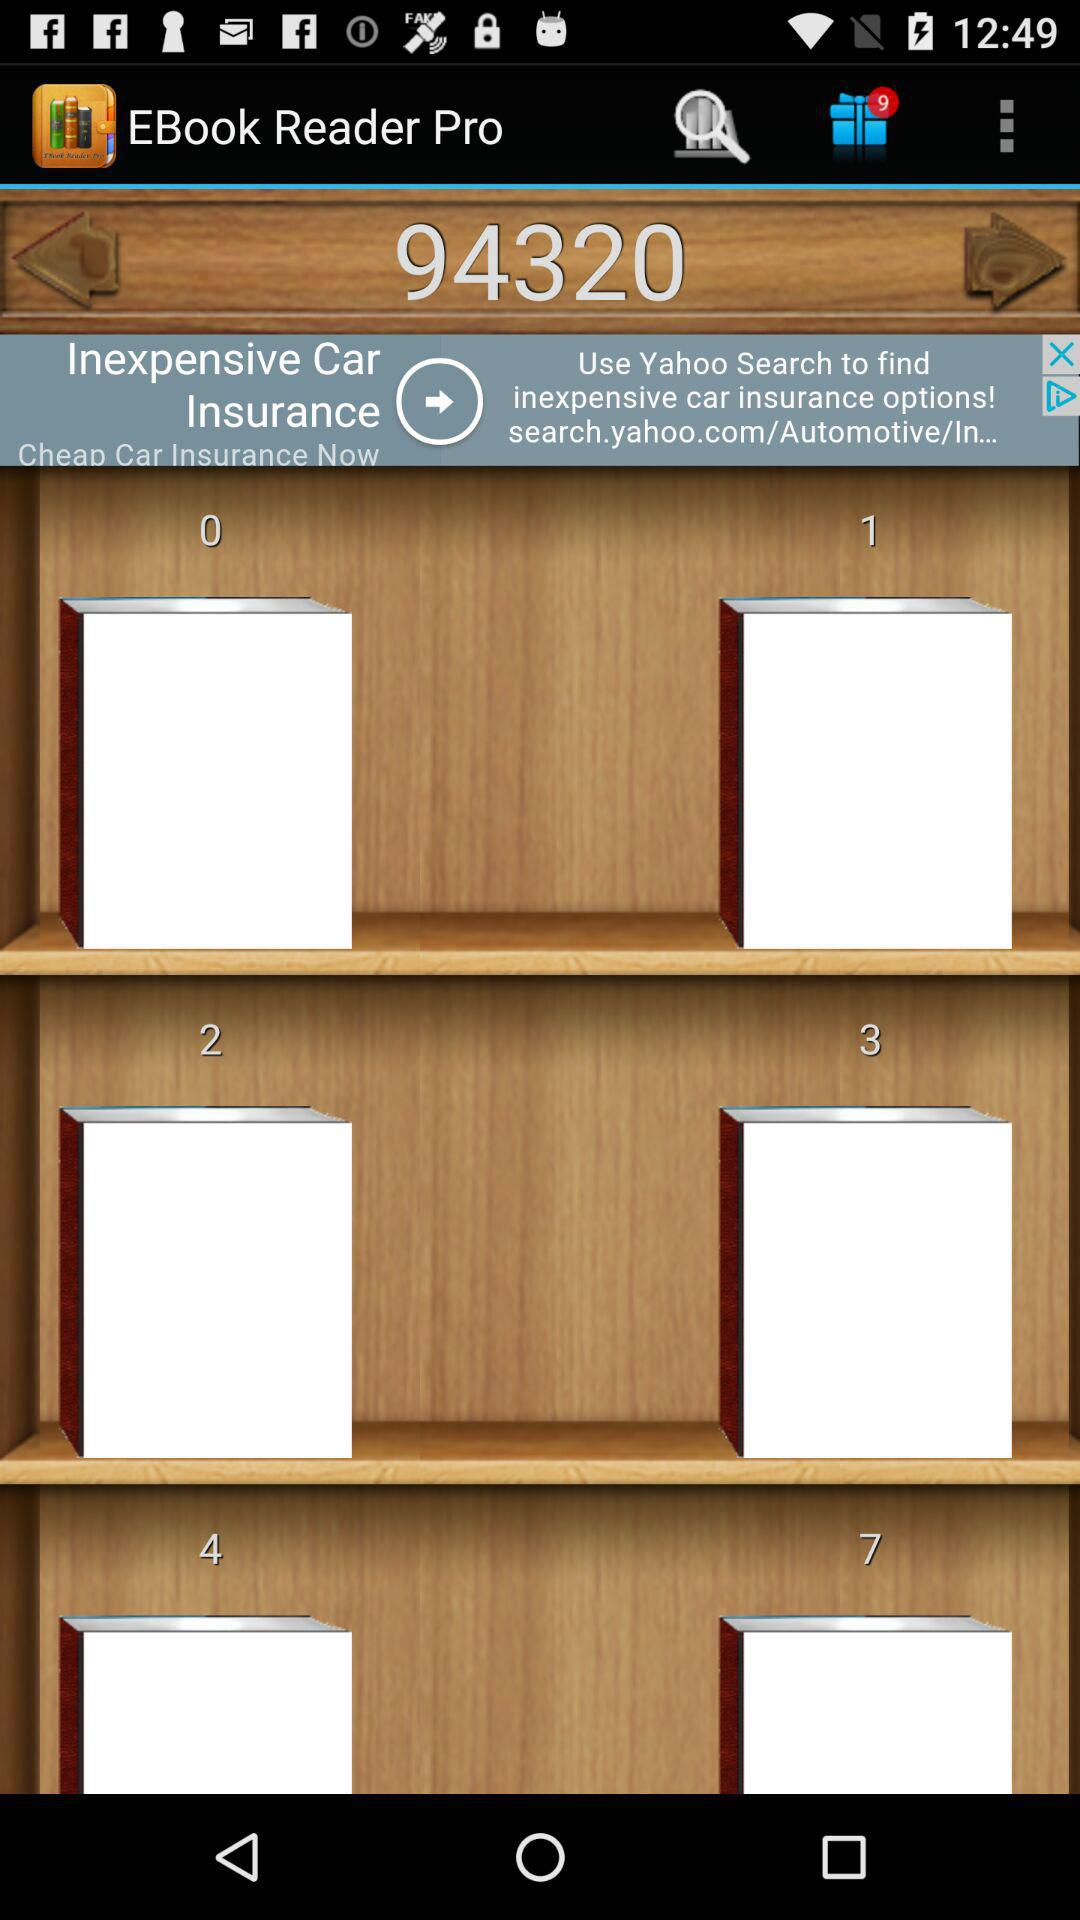How many gift notifications are there? There are 9 gift notifications. 